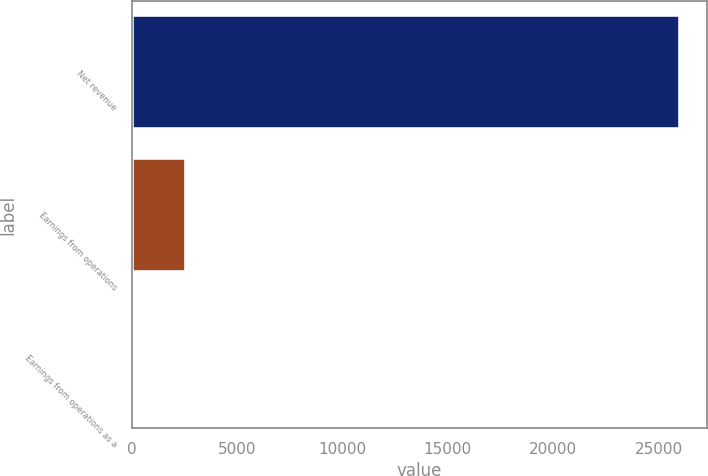Convert chart to OTSL. <chart><loc_0><loc_0><loc_500><loc_500><bar_chart><fcel>Net revenue<fcel>Earnings from operations<fcel>Earnings from operations as a<nl><fcel>25993<fcel>2602.9<fcel>4<nl></chart> 